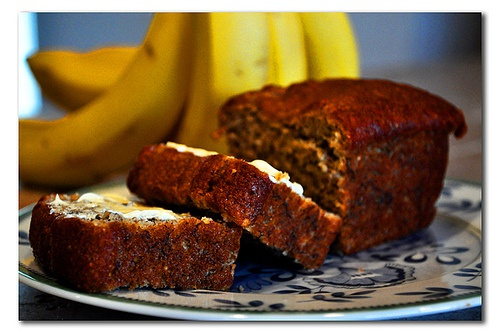Describe the objects in this image and their specific colors. I can see banana in white, olive, maroon, orange, and khaki tones, cake in white, maroon, black, and brown tones, cake in white, black, maroon, ivory, and brown tones, and cake in white, maroon, black, and beige tones in this image. 